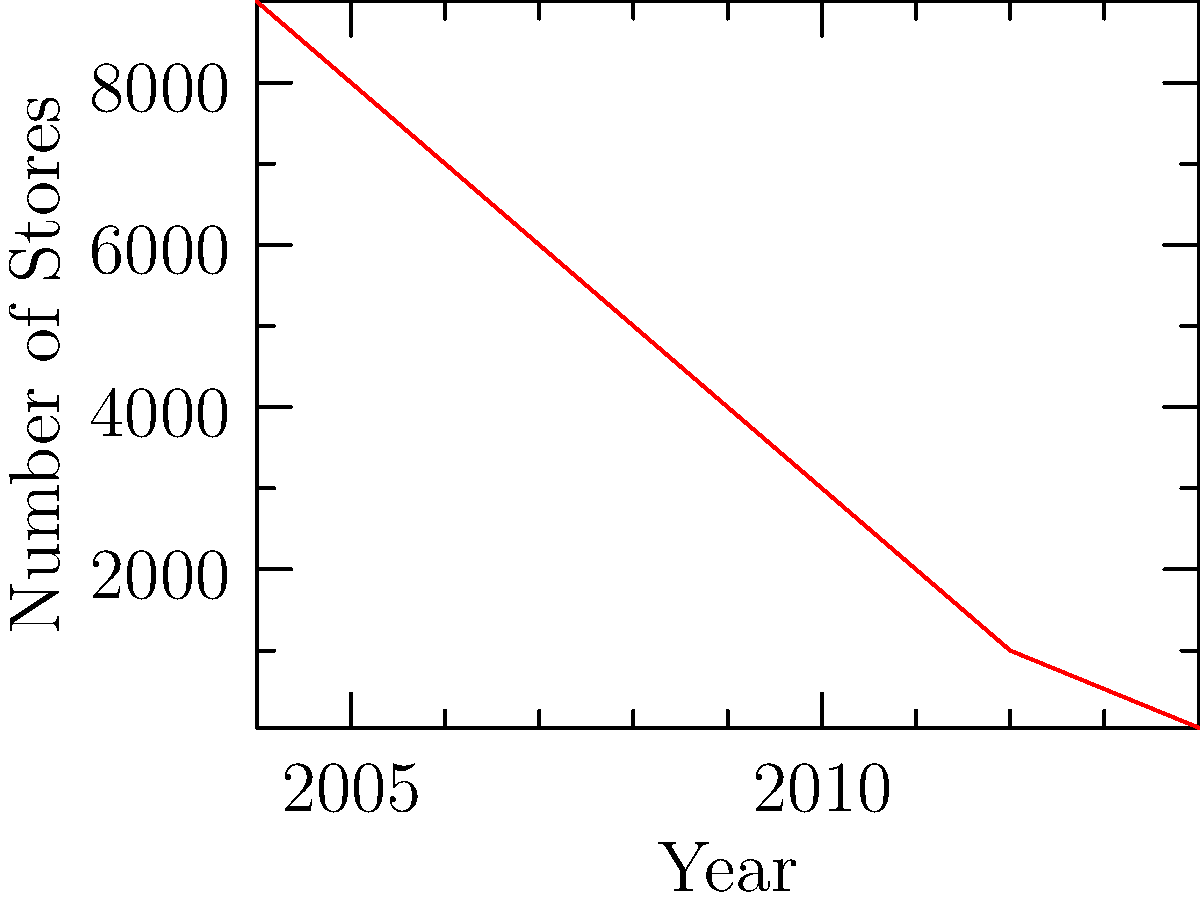The graph shows the decline of Blockbuster store locations from 2004 to 2014. Calculate the average rate of decline in the number of stores per year during this period. To calculate the average rate of decline per year:

1. Find the total decline:
   Initial stores (2004): 9000
   Final stores (2014): 50
   Total decline = 9000 - 50 = 8950 stores

2. Determine the time period:
   2014 - 2004 = 10 years

3. Calculate the average rate of decline per year:
   Average rate = Total decline ÷ Number of years
   $\frac{8950}{10} = 895$ stores per year

Therefore, on average, Blockbuster lost 895 stores per year from 2004 to 2014.
Answer: 895 stores per year 